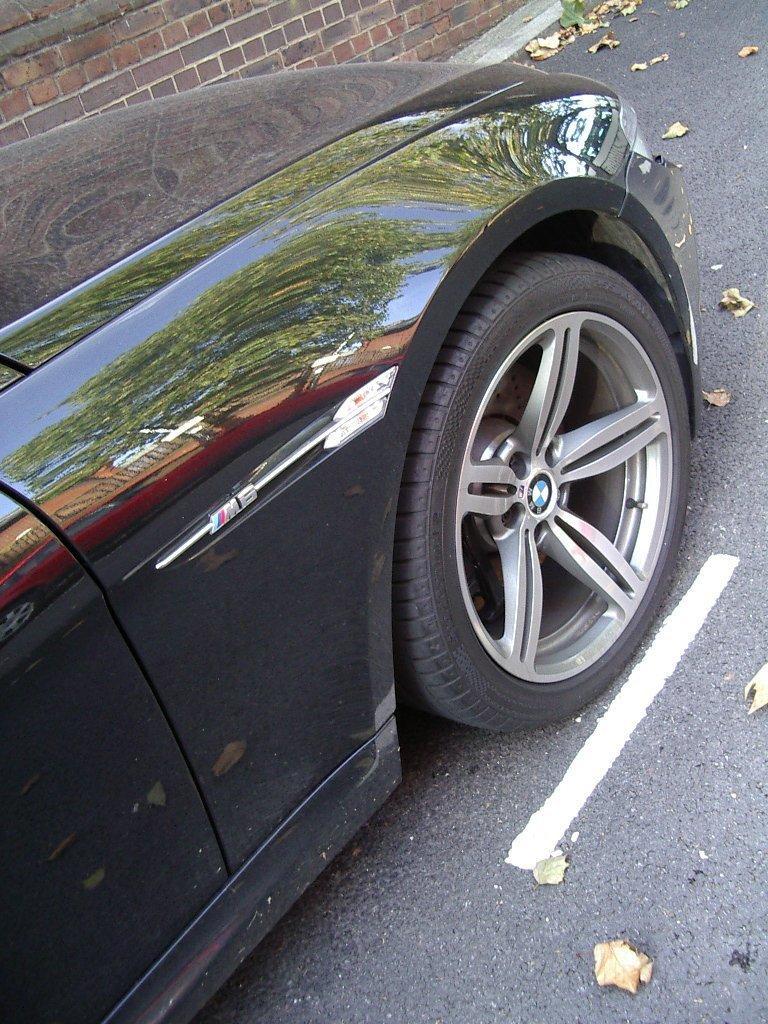Please provide a concise description of this image. In this image we can see a car which is in black color. At the bottom there is a road. In the background there is a wall. 